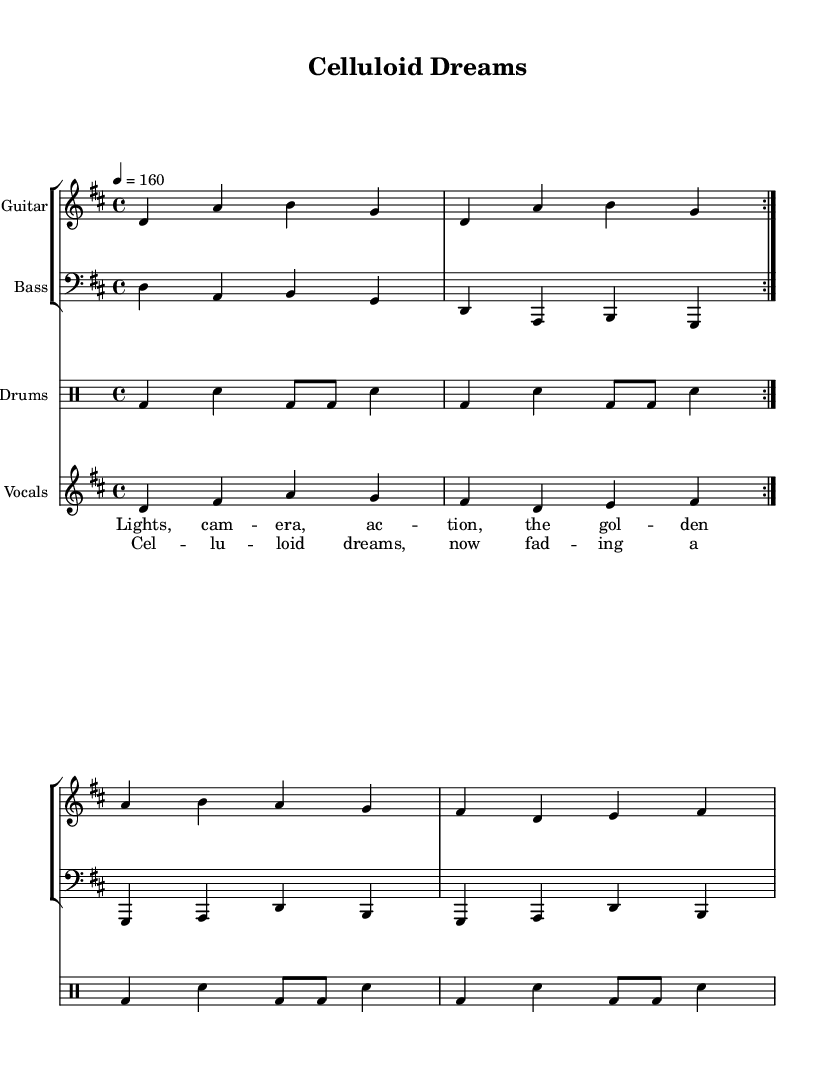What is the key signature of this music? The key signature is D major, which has two sharps (F# and C#). You can identify the key signature typically at the beginning of the sheet music, and it indicates the notes that are sharp throughout the piece.
Answer: D major What is the time signature of the piece? The time signature is 4/4, which is indicated at the beginning of the score. This means there are four beats in each measure, and the quarter note gets one beat.
Answer: 4/4 What is the tempo marking of the music? The tempo marking is quarter note equals 160. This can be found where the tempo is specified, indicating how fast the piece should be played.
Answer: 160 How many times are the guitar and bass sections repeated? Both the guitar and bass sections are repeated twice, as indicated by the "volta" notation in the score. This signifies that those measures should be played twice in succession.
Answer: 2 What is the theme of the lyrics in the chorus? The theme of the lyrics in the chorus reflects on the fading legacy of Hollywood's golden age, using the metaphor "celluloid dreams" and the phrase "rise and fall of yesterday" to underline nostalgia and loss. The context of the pop-punk genre enhances this theme of youthful rebellion against the established norms of classic Hollywood.
Answer: Nostalgia and loss What type of drums are used in this piece? The piece employs a standard rock drum kit, as indicated by the notation in the drum section, featuring bass drums (bd) and snare drums (sn). This type of drumming is typical for punk music, emphasizing a driving rhythm.
Answer: Standard rock kit Which instruments are included in this score? The score includes guitar, bass, drums, and vocals. Each instrument is represented with its own staff, showing how they collaborate to create the overall sound of the piece.
Answer: Guitar, bass, drums, vocals 